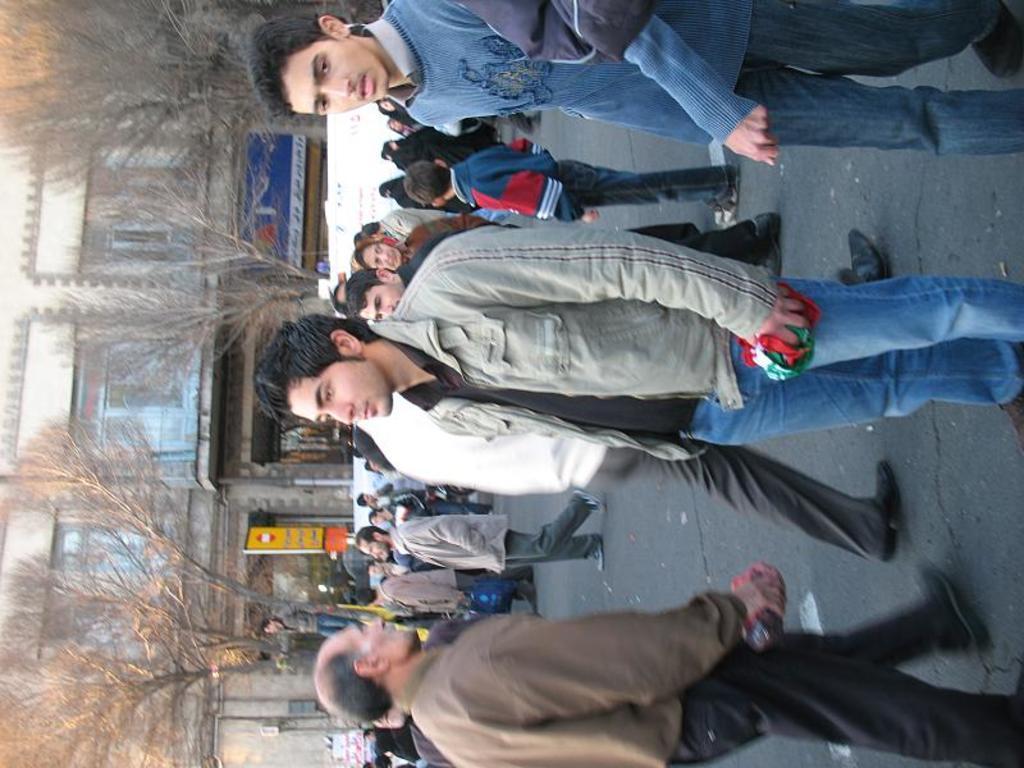How would you summarize this image in a sentence or two? This picture describes about group of people, few are standing and few are walking, in the background we can see few trees, hoardings and buildings. 